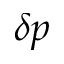Convert formula to latex. <formula><loc_0><loc_0><loc_500><loc_500>\delta p</formula> 